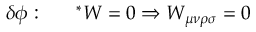Convert formula to latex. <formula><loc_0><loc_0><loc_500><loc_500>\delta { \phi } \colon ^ { * } W = 0 \Rightarrow W _ { \mu \nu \rho \sigma } = 0</formula> 